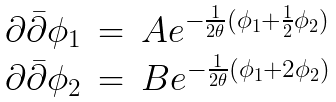Convert formula to latex. <formula><loc_0><loc_0><loc_500><loc_500>\begin{array} { l c l } { { \partial { \bar { \partial } } \phi _ { 1 } } } & { = } & { { A e ^ { - \frac { 1 } { 2 \theta } ( \phi _ { 1 } + \frac { 1 } { 2 } \phi _ { 2 } ) } } } \\ { { \partial { \bar { \partial } } \phi _ { 2 } } } & { = } & { { B e ^ { - \frac { 1 } { 2 \theta } ( \phi _ { 1 } + 2 \phi _ { 2 } ) } } } \end{array}</formula> 